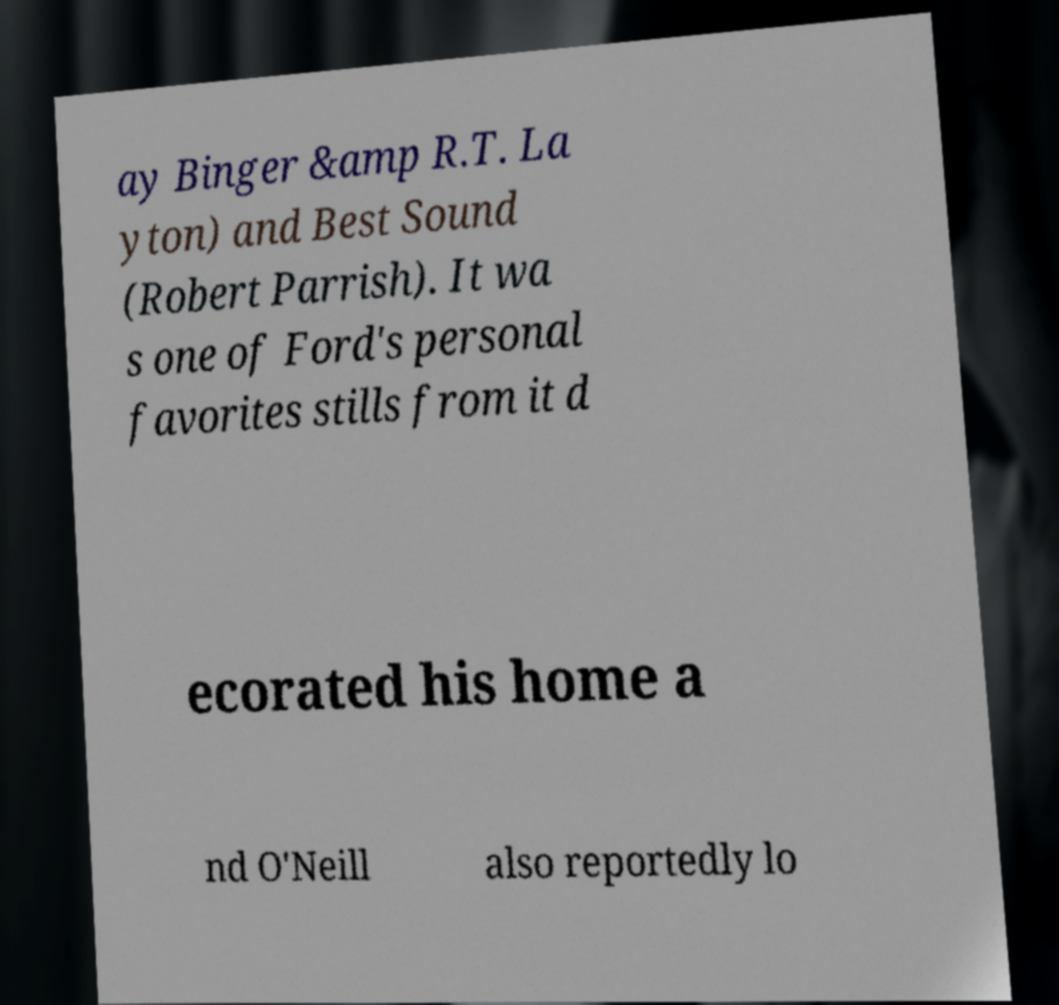Could you assist in decoding the text presented in this image and type it out clearly? ay Binger &amp R.T. La yton) and Best Sound (Robert Parrish). It wa s one of Ford's personal favorites stills from it d ecorated his home a nd O'Neill also reportedly lo 